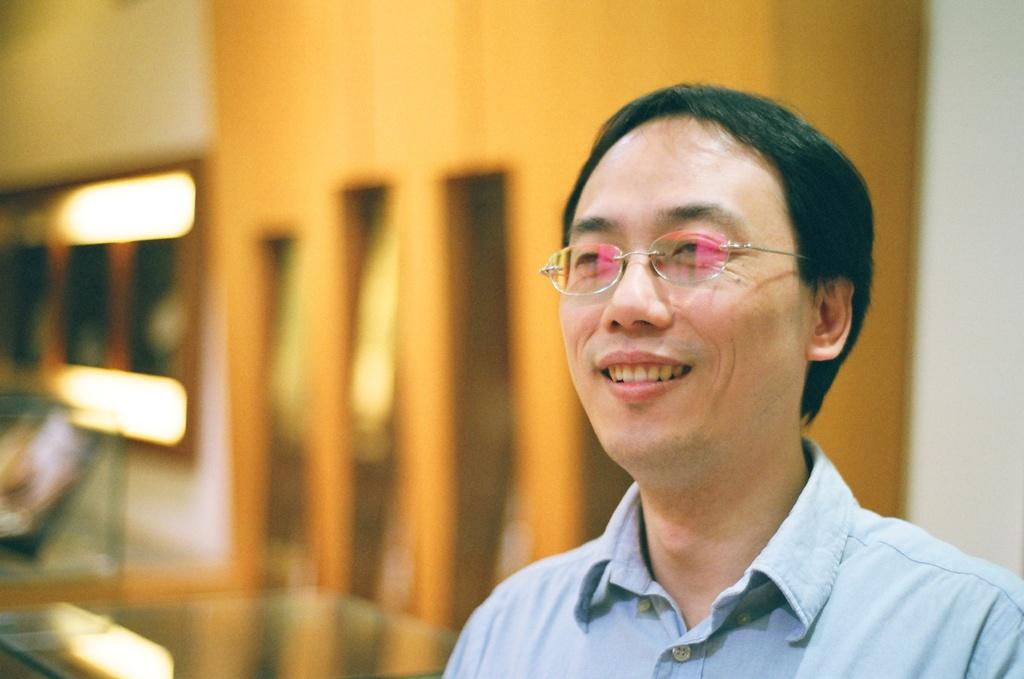What can be seen in the image? There is a person in the image. What is the person wearing? The person is wearing a shirt and spectacles. How is the person's facial expression? The person is smiling. Can you describe the background of the image? The background of the image is blurred. What is the person's voice like in the image? The image is a still photograph, so there is no sound or voice present. 